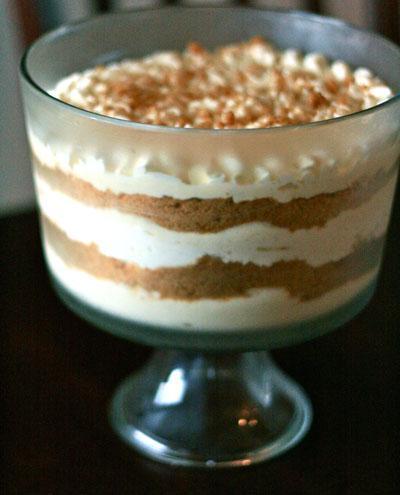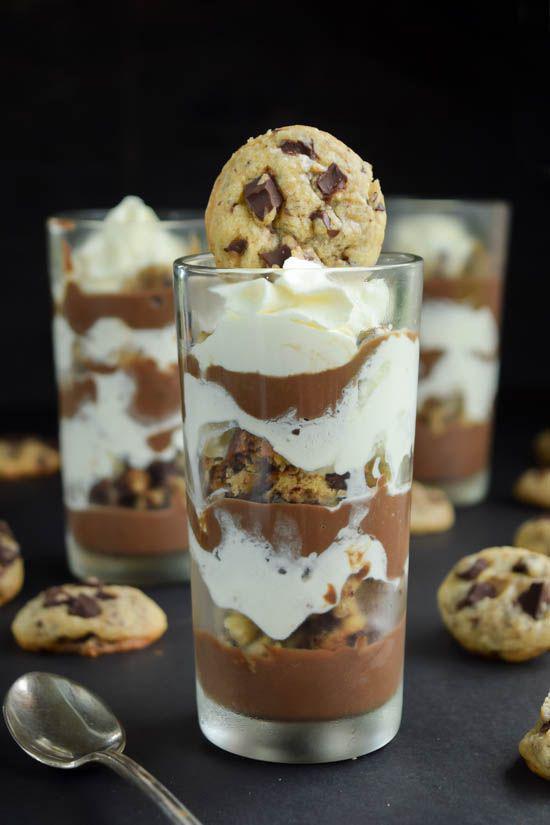The first image is the image on the left, the second image is the image on the right. Evaluate the accuracy of this statement regarding the images: "One image shows a large dessert in a clear glass footed bowl, while the second image shows three individual layered desserts in glasses.". Is it true? Answer yes or no. Yes. The first image is the image on the left, the second image is the image on the right. Evaluate the accuracy of this statement regarding the images: "There are three cups of dessert in the image on the left.". Is it true? Answer yes or no. No. 